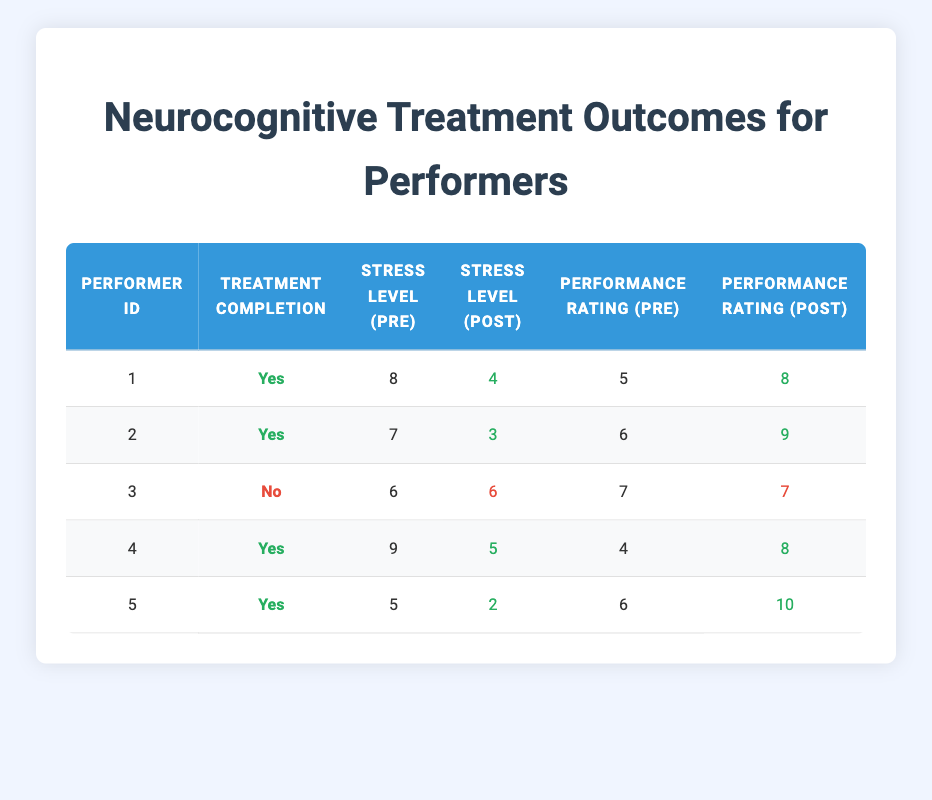What is the stress level of Performer 1 before treatment? Referring to the table, the "Stress Level (Pre)" for Performer 1 is listed as 8.
Answer: 8 How many performers completed the treatment? The table indicates that there are 5 performers, and the "Treatment Completion" column shows that 4 performers completed treatment (marked as "Yes").
Answer: 4 What was the performance rating after treatment for Performer 5? The table shows that the "Performance Rating (Post)" for Performer 5 is 10.
Answer: 10 Which performer experienced the highest decrease in stress levels post-treatment? To find this, we calculate the decreases: Performer 1 from 8 to 4 (4), Performer 2 from 7 to 3 (4), Performer 4 from 9 to 5 (4), and Performer 5 from 5 to 2 (3). All of these have the highest decrease of 4, with multiple performers sharing this value. Therefore, they are tied for the highest decrease.
Answer: Performer 1, Performer 2, Performer 4 Did Performer 3 show any change in performance rating before and after treatment? Analyzing the table for Performer 3, the "Performance Rating (Pre)" is 7 and the "Performance Rating (Post)" is also 7. Therefore, there was no change in performance.
Answer: No What is the average stress level after treatment for all performers who completed the treatment? The "Stress Level (Post)" for the performers who completed treatment (1, 2, 4, 5) are 4, 3, 5, and 2. The sum is 14, and dividing by the number of performers (4), the average is 14/4 = 3.5.
Answer: 3.5 Did any performer report an increase in their performance rating after treatment? Reviewing the performance ratings post-treatment, Performers 1, 2, 4, and 5 all show an increase in performance ratings (8, 9, 8, and 10, respectively). Thus, it can be concluded that yes, there were performers who reported an increase.
Answer: Yes How does the stress reduction correlate with performance improvement among the performers who completed treatment? Observing the table, all performers who completed treatment exhibited stress reductions and also increased their performance ratings. Performer 1 reduced stress from 8 to 4 and improved performance from 5 to 8. Performer 2 reduced stress from 7 to 3 and improved from 6 to 9. Performer 4 reduced from 9 to 5 and improved from 4 to 8. Performer 5's stress reduced from 5 to 2 and performance increased from 6 to 10. Thus, there is a positive correlation between stress reduction and performance improvement among these performers.
Answer: Positive correlation 